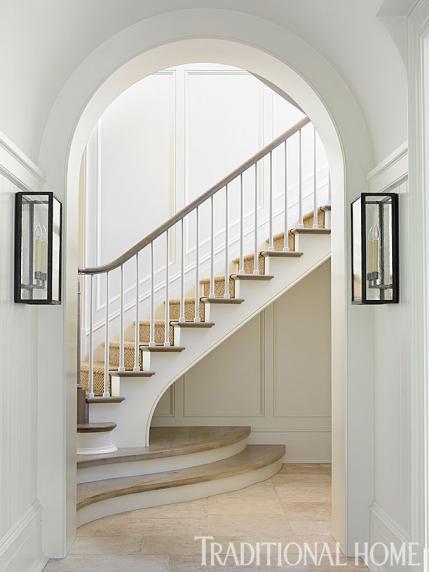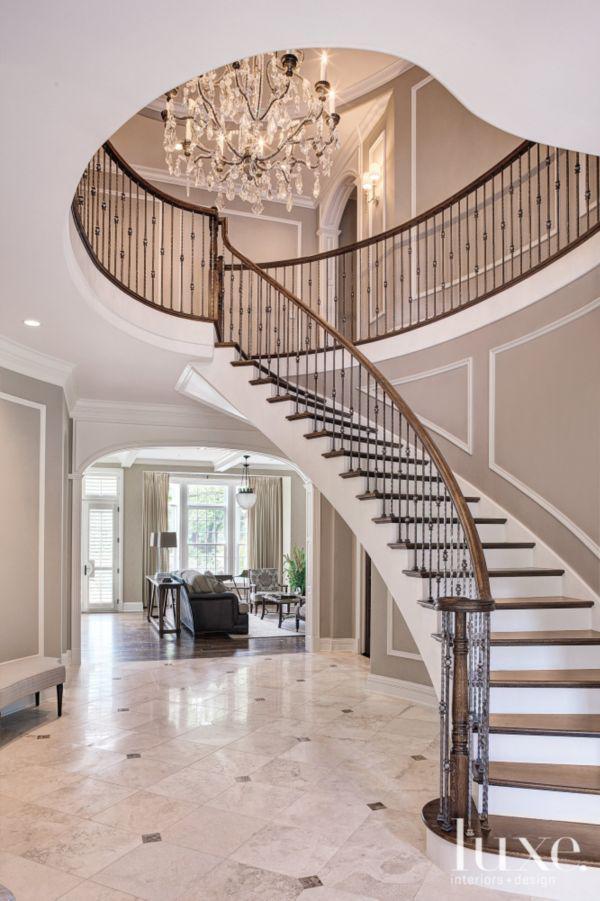The first image is the image on the left, the second image is the image on the right. For the images shown, is this caption "The stairs in each image are going up toward the other image." true? Answer yes or no. Yes. The first image is the image on the left, the second image is the image on the right. For the images shown, is this caption "There is a curved staircase." true? Answer yes or no. Yes. 